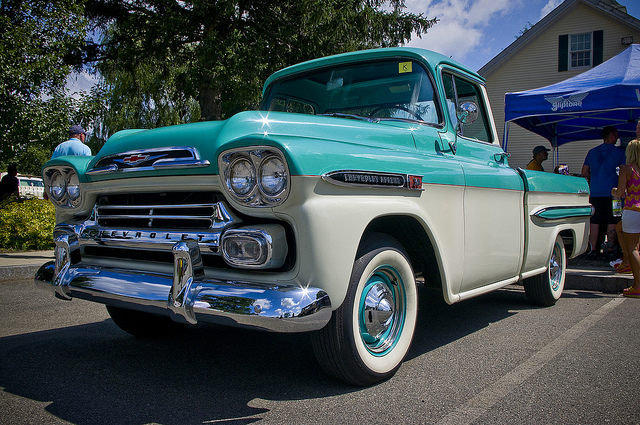Can you describe a realistic scenario where this truck might be used today in a short response? In a modern context, this classic truck might be used in a local parade, showcasing its vintage charm and representing historical vehicle enthusiasts. 